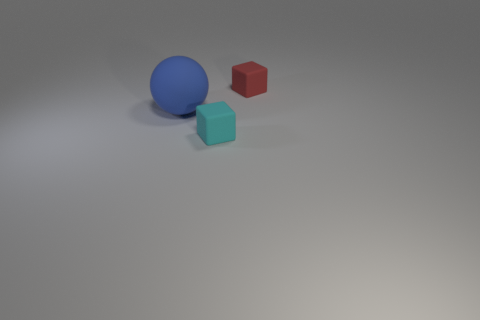Are there any other things that have the same shape as the large thing?
Provide a short and direct response. No. Do the big blue ball and the small cyan thing that is in front of the blue rubber thing have the same material?
Offer a terse response. Yes. What is the material of the small object to the left of the matte block that is behind the ball?
Give a very brief answer. Rubber. Is the number of blue objects on the right side of the big rubber thing greater than the number of cyan objects?
Keep it short and to the point. No. Are there any small cyan rubber objects?
Provide a succinct answer. Yes. What color is the thing that is on the left side of the small cyan rubber cube?
Offer a terse response. Blue. There is a red block that is the same size as the cyan object; what is its material?
Give a very brief answer. Rubber. What number of other things are there of the same material as the big blue ball
Ensure brevity in your answer.  2. What is the color of the rubber thing that is both behind the cyan rubber block and to the right of the big rubber object?
Give a very brief answer. Red. How many objects are things behind the blue matte object or big green cylinders?
Make the answer very short. 1. 